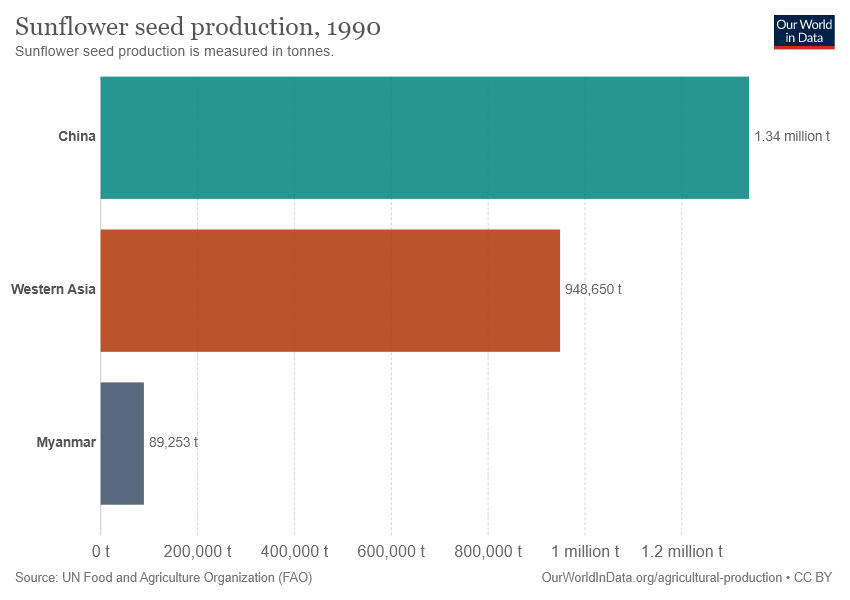Indicate a few pertinent items in this graphic. The value of China is greater than the combined total of two other countries. The value of China in the chart is 1.34. 